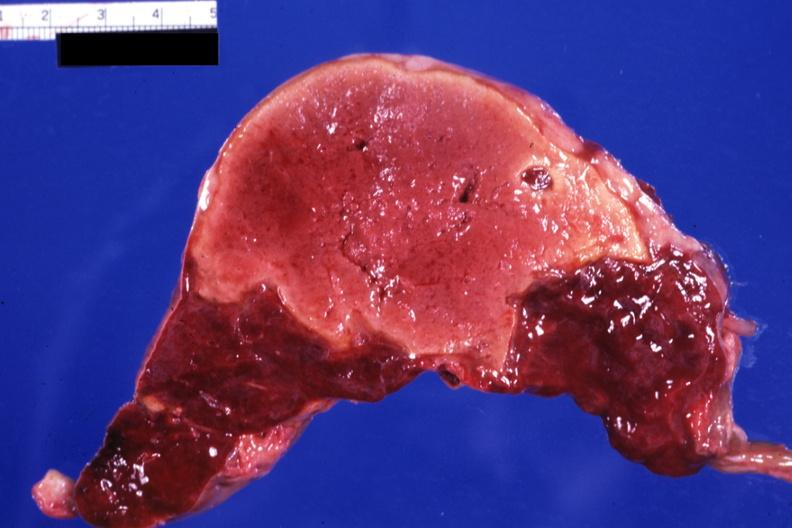s pinworm present?
Answer the question using a single word or phrase. No 